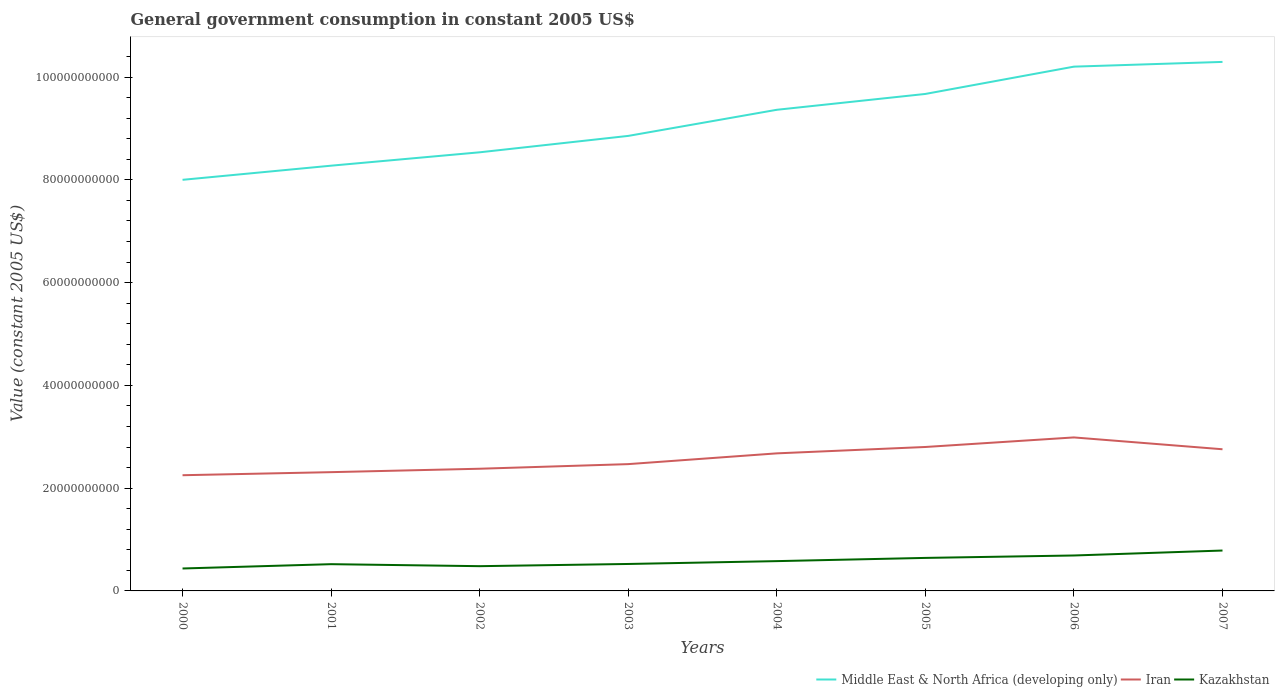Does the line corresponding to Middle East & North Africa (developing only) intersect with the line corresponding to Kazakhstan?
Your response must be concise. No. Across all years, what is the maximum government conusmption in Kazakhstan?
Offer a very short reply. 4.37e+09. What is the total government conusmption in Middle East & North Africa (developing only) in the graph?
Offer a terse response. -2.75e+09. What is the difference between the highest and the second highest government conusmption in Kazakhstan?
Provide a short and direct response. 3.49e+09. Is the government conusmption in Kazakhstan strictly greater than the government conusmption in Iran over the years?
Provide a succinct answer. Yes. How many lines are there?
Your response must be concise. 3. Are the values on the major ticks of Y-axis written in scientific E-notation?
Your answer should be very brief. No. How are the legend labels stacked?
Offer a terse response. Horizontal. What is the title of the graph?
Keep it short and to the point. General government consumption in constant 2005 US$. What is the label or title of the X-axis?
Offer a very short reply. Years. What is the label or title of the Y-axis?
Make the answer very short. Value (constant 2005 US$). What is the Value (constant 2005 US$) of Middle East & North Africa (developing only) in 2000?
Offer a very short reply. 8.00e+1. What is the Value (constant 2005 US$) of Iran in 2000?
Make the answer very short. 2.25e+1. What is the Value (constant 2005 US$) of Kazakhstan in 2000?
Keep it short and to the point. 4.37e+09. What is the Value (constant 2005 US$) in Middle East & North Africa (developing only) in 2001?
Your response must be concise. 8.28e+1. What is the Value (constant 2005 US$) in Iran in 2001?
Your answer should be compact. 2.31e+1. What is the Value (constant 2005 US$) in Kazakhstan in 2001?
Keep it short and to the point. 5.21e+09. What is the Value (constant 2005 US$) in Middle East & North Africa (developing only) in 2002?
Offer a very short reply. 8.54e+1. What is the Value (constant 2005 US$) in Iran in 2002?
Your answer should be compact. 2.38e+1. What is the Value (constant 2005 US$) of Kazakhstan in 2002?
Ensure brevity in your answer.  4.81e+09. What is the Value (constant 2005 US$) of Middle East & North Africa (developing only) in 2003?
Provide a short and direct response. 8.85e+1. What is the Value (constant 2005 US$) of Iran in 2003?
Provide a succinct answer. 2.47e+1. What is the Value (constant 2005 US$) in Kazakhstan in 2003?
Offer a terse response. 5.24e+09. What is the Value (constant 2005 US$) in Middle East & North Africa (developing only) in 2004?
Offer a very short reply. 9.36e+1. What is the Value (constant 2005 US$) in Iran in 2004?
Offer a very short reply. 2.68e+1. What is the Value (constant 2005 US$) of Kazakhstan in 2004?
Provide a short and direct response. 5.80e+09. What is the Value (constant 2005 US$) in Middle East & North Africa (developing only) in 2005?
Provide a succinct answer. 9.67e+1. What is the Value (constant 2005 US$) of Iran in 2005?
Keep it short and to the point. 2.80e+1. What is the Value (constant 2005 US$) of Kazakhstan in 2005?
Provide a succinct answer. 6.43e+09. What is the Value (constant 2005 US$) in Middle East & North Africa (developing only) in 2006?
Keep it short and to the point. 1.02e+11. What is the Value (constant 2005 US$) of Iran in 2006?
Your answer should be very brief. 2.99e+1. What is the Value (constant 2005 US$) of Kazakhstan in 2006?
Your answer should be very brief. 6.89e+09. What is the Value (constant 2005 US$) of Middle East & North Africa (developing only) in 2007?
Your response must be concise. 1.03e+11. What is the Value (constant 2005 US$) in Iran in 2007?
Provide a succinct answer. 2.76e+1. What is the Value (constant 2005 US$) in Kazakhstan in 2007?
Your answer should be compact. 7.86e+09. Across all years, what is the maximum Value (constant 2005 US$) in Middle East & North Africa (developing only)?
Give a very brief answer. 1.03e+11. Across all years, what is the maximum Value (constant 2005 US$) in Iran?
Your response must be concise. 2.99e+1. Across all years, what is the maximum Value (constant 2005 US$) in Kazakhstan?
Offer a very short reply. 7.86e+09. Across all years, what is the minimum Value (constant 2005 US$) in Middle East & North Africa (developing only)?
Make the answer very short. 8.00e+1. Across all years, what is the minimum Value (constant 2005 US$) in Iran?
Offer a terse response. 2.25e+1. Across all years, what is the minimum Value (constant 2005 US$) of Kazakhstan?
Offer a terse response. 4.37e+09. What is the total Value (constant 2005 US$) in Middle East & North Africa (developing only) in the graph?
Provide a short and direct response. 7.32e+11. What is the total Value (constant 2005 US$) in Iran in the graph?
Your answer should be very brief. 2.06e+11. What is the total Value (constant 2005 US$) of Kazakhstan in the graph?
Keep it short and to the point. 4.66e+1. What is the difference between the Value (constant 2005 US$) of Middle East & North Africa (developing only) in 2000 and that in 2001?
Offer a very short reply. -2.75e+09. What is the difference between the Value (constant 2005 US$) of Iran in 2000 and that in 2001?
Your answer should be very brief. -5.96e+08. What is the difference between the Value (constant 2005 US$) of Kazakhstan in 2000 and that in 2001?
Make the answer very short. -8.38e+08. What is the difference between the Value (constant 2005 US$) in Middle East & North Africa (developing only) in 2000 and that in 2002?
Provide a short and direct response. -5.36e+09. What is the difference between the Value (constant 2005 US$) of Iran in 2000 and that in 2002?
Keep it short and to the point. -1.26e+09. What is the difference between the Value (constant 2005 US$) in Kazakhstan in 2000 and that in 2002?
Provide a succinct answer. -4.48e+08. What is the difference between the Value (constant 2005 US$) in Middle East & North Africa (developing only) in 2000 and that in 2003?
Ensure brevity in your answer.  -8.55e+09. What is the difference between the Value (constant 2005 US$) in Iran in 2000 and that in 2003?
Provide a short and direct response. -2.16e+09. What is the difference between the Value (constant 2005 US$) in Kazakhstan in 2000 and that in 2003?
Your answer should be compact. -8.77e+08. What is the difference between the Value (constant 2005 US$) in Middle East & North Africa (developing only) in 2000 and that in 2004?
Give a very brief answer. -1.36e+1. What is the difference between the Value (constant 2005 US$) of Iran in 2000 and that in 2004?
Your answer should be very brief. -4.26e+09. What is the difference between the Value (constant 2005 US$) in Kazakhstan in 2000 and that in 2004?
Keep it short and to the point. -1.43e+09. What is the difference between the Value (constant 2005 US$) in Middle East & North Africa (developing only) in 2000 and that in 2005?
Your answer should be compact. -1.67e+1. What is the difference between the Value (constant 2005 US$) in Iran in 2000 and that in 2005?
Your response must be concise. -5.49e+09. What is the difference between the Value (constant 2005 US$) in Kazakhstan in 2000 and that in 2005?
Keep it short and to the point. -2.06e+09. What is the difference between the Value (constant 2005 US$) of Middle East & North Africa (developing only) in 2000 and that in 2006?
Provide a short and direct response. -2.20e+1. What is the difference between the Value (constant 2005 US$) of Iran in 2000 and that in 2006?
Make the answer very short. -7.36e+09. What is the difference between the Value (constant 2005 US$) in Kazakhstan in 2000 and that in 2006?
Offer a terse response. -2.53e+09. What is the difference between the Value (constant 2005 US$) in Middle East & North Africa (developing only) in 2000 and that in 2007?
Your answer should be very brief. -2.29e+1. What is the difference between the Value (constant 2005 US$) in Iran in 2000 and that in 2007?
Provide a short and direct response. -5.05e+09. What is the difference between the Value (constant 2005 US$) in Kazakhstan in 2000 and that in 2007?
Your answer should be compact. -3.49e+09. What is the difference between the Value (constant 2005 US$) in Middle East & North Africa (developing only) in 2001 and that in 2002?
Your response must be concise. -2.60e+09. What is the difference between the Value (constant 2005 US$) in Iran in 2001 and that in 2002?
Your response must be concise. -6.67e+08. What is the difference between the Value (constant 2005 US$) in Kazakhstan in 2001 and that in 2002?
Your answer should be compact. 3.90e+08. What is the difference between the Value (constant 2005 US$) in Middle East & North Africa (developing only) in 2001 and that in 2003?
Your answer should be compact. -5.79e+09. What is the difference between the Value (constant 2005 US$) of Iran in 2001 and that in 2003?
Your response must be concise. -1.56e+09. What is the difference between the Value (constant 2005 US$) in Kazakhstan in 2001 and that in 2003?
Provide a short and direct response. -3.81e+07. What is the difference between the Value (constant 2005 US$) in Middle East & North Africa (developing only) in 2001 and that in 2004?
Ensure brevity in your answer.  -1.09e+1. What is the difference between the Value (constant 2005 US$) of Iran in 2001 and that in 2004?
Make the answer very short. -3.66e+09. What is the difference between the Value (constant 2005 US$) of Kazakhstan in 2001 and that in 2004?
Your response must be concise. -5.94e+08. What is the difference between the Value (constant 2005 US$) in Middle East & North Africa (developing only) in 2001 and that in 2005?
Provide a short and direct response. -1.40e+1. What is the difference between the Value (constant 2005 US$) in Iran in 2001 and that in 2005?
Provide a succinct answer. -4.90e+09. What is the difference between the Value (constant 2005 US$) in Kazakhstan in 2001 and that in 2005?
Give a very brief answer. -1.22e+09. What is the difference between the Value (constant 2005 US$) in Middle East & North Africa (developing only) in 2001 and that in 2006?
Give a very brief answer. -1.93e+1. What is the difference between the Value (constant 2005 US$) of Iran in 2001 and that in 2006?
Ensure brevity in your answer.  -6.76e+09. What is the difference between the Value (constant 2005 US$) in Kazakhstan in 2001 and that in 2006?
Ensure brevity in your answer.  -1.69e+09. What is the difference between the Value (constant 2005 US$) in Middle East & North Africa (developing only) in 2001 and that in 2007?
Ensure brevity in your answer.  -2.02e+1. What is the difference between the Value (constant 2005 US$) of Iran in 2001 and that in 2007?
Make the answer very short. -4.46e+09. What is the difference between the Value (constant 2005 US$) of Kazakhstan in 2001 and that in 2007?
Your response must be concise. -2.65e+09. What is the difference between the Value (constant 2005 US$) of Middle East & North Africa (developing only) in 2002 and that in 2003?
Give a very brief answer. -3.19e+09. What is the difference between the Value (constant 2005 US$) in Iran in 2002 and that in 2003?
Your answer should be compact. -8.97e+08. What is the difference between the Value (constant 2005 US$) of Kazakhstan in 2002 and that in 2003?
Offer a terse response. -4.29e+08. What is the difference between the Value (constant 2005 US$) of Middle East & North Africa (developing only) in 2002 and that in 2004?
Make the answer very short. -8.27e+09. What is the difference between the Value (constant 2005 US$) in Iran in 2002 and that in 2004?
Give a very brief answer. -2.99e+09. What is the difference between the Value (constant 2005 US$) in Kazakhstan in 2002 and that in 2004?
Your answer should be very brief. -9.84e+08. What is the difference between the Value (constant 2005 US$) in Middle East & North Africa (developing only) in 2002 and that in 2005?
Make the answer very short. -1.14e+1. What is the difference between the Value (constant 2005 US$) of Iran in 2002 and that in 2005?
Your response must be concise. -4.23e+09. What is the difference between the Value (constant 2005 US$) in Kazakhstan in 2002 and that in 2005?
Offer a terse response. -1.61e+09. What is the difference between the Value (constant 2005 US$) of Middle East & North Africa (developing only) in 2002 and that in 2006?
Offer a terse response. -1.67e+1. What is the difference between the Value (constant 2005 US$) in Iran in 2002 and that in 2006?
Provide a short and direct response. -6.09e+09. What is the difference between the Value (constant 2005 US$) of Kazakhstan in 2002 and that in 2006?
Make the answer very short. -2.08e+09. What is the difference between the Value (constant 2005 US$) of Middle East & North Africa (developing only) in 2002 and that in 2007?
Keep it short and to the point. -1.76e+1. What is the difference between the Value (constant 2005 US$) in Iran in 2002 and that in 2007?
Make the answer very short. -3.79e+09. What is the difference between the Value (constant 2005 US$) of Kazakhstan in 2002 and that in 2007?
Make the answer very short. -3.04e+09. What is the difference between the Value (constant 2005 US$) in Middle East & North Africa (developing only) in 2003 and that in 2004?
Your answer should be very brief. -5.08e+09. What is the difference between the Value (constant 2005 US$) in Iran in 2003 and that in 2004?
Ensure brevity in your answer.  -2.09e+09. What is the difference between the Value (constant 2005 US$) of Kazakhstan in 2003 and that in 2004?
Make the answer very short. -5.56e+08. What is the difference between the Value (constant 2005 US$) in Middle East & North Africa (developing only) in 2003 and that in 2005?
Keep it short and to the point. -8.17e+09. What is the difference between the Value (constant 2005 US$) of Iran in 2003 and that in 2005?
Keep it short and to the point. -3.33e+09. What is the difference between the Value (constant 2005 US$) of Kazakhstan in 2003 and that in 2005?
Your answer should be compact. -1.18e+09. What is the difference between the Value (constant 2005 US$) of Middle East & North Africa (developing only) in 2003 and that in 2006?
Offer a terse response. -1.35e+1. What is the difference between the Value (constant 2005 US$) of Iran in 2003 and that in 2006?
Ensure brevity in your answer.  -5.19e+09. What is the difference between the Value (constant 2005 US$) in Kazakhstan in 2003 and that in 2006?
Ensure brevity in your answer.  -1.65e+09. What is the difference between the Value (constant 2005 US$) of Middle East & North Africa (developing only) in 2003 and that in 2007?
Give a very brief answer. -1.44e+1. What is the difference between the Value (constant 2005 US$) in Iran in 2003 and that in 2007?
Your response must be concise. -2.89e+09. What is the difference between the Value (constant 2005 US$) in Kazakhstan in 2003 and that in 2007?
Give a very brief answer. -2.62e+09. What is the difference between the Value (constant 2005 US$) of Middle East & North Africa (developing only) in 2004 and that in 2005?
Your answer should be compact. -3.08e+09. What is the difference between the Value (constant 2005 US$) in Iran in 2004 and that in 2005?
Your answer should be compact. -1.24e+09. What is the difference between the Value (constant 2005 US$) in Kazakhstan in 2004 and that in 2005?
Your response must be concise. -6.26e+08. What is the difference between the Value (constant 2005 US$) of Middle East & North Africa (developing only) in 2004 and that in 2006?
Your answer should be very brief. -8.40e+09. What is the difference between the Value (constant 2005 US$) of Iran in 2004 and that in 2006?
Your answer should be compact. -3.10e+09. What is the difference between the Value (constant 2005 US$) of Kazakhstan in 2004 and that in 2006?
Offer a very short reply. -1.10e+09. What is the difference between the Value (constant 2005 US$) in Middle East & North Africa (developing only) in 2004 and that in 2007?
Provide a succinct answer. -9.32e+09. What is the difference between the Value (constant 2005 US$) of Iran in 2004 and that in 2007?
Offer a terse response. -7.97e+08. What is the difference between the Value (constant 2005 US$) in Kazakhstan in 2004 and that in 2007?
Offer a terse response. -2.06e+09. What is the difference between the Value (constant 2005 US$) in Middle East & North Africa (developing only) in 2005 and that in 2006?
Keep it short and to the point. -5.31e+09. What is the difference between the Value (constant 2005 US$) in Iran in 2005 and that in 2006?
Give a very brief answer. -1.86e+09. What is the difference between the Value (constant 2005 US$) in Kazakhstan in 2005 and that in 2006?
Ensure brevity in your answer.  -4.69e+08. What is the difference between the Value (constant 2005 US$) in Middle East & North Africa (developing only) in 2005 and that in 2007?
Your answer should be very brief. -6.23e+09. What is the difference between the Value (constant 2005 US$) in Iran in 2005 and that in 2007?
Keep it short and to the point. 4.43e+08. What is the difference between the Value (constant 2005 US$) in Kazakhstan in 2005 and that in 2007?
Give a very brief answer. -1.43e+09. What is the difference between the Value (constant 2005 US$) in Middle East & North Africa (developing only) in 2006 and that in 2007?
Keep it short and to the point. -9.21e+08. What is the difference between the Value (constant 2005 US$) of Iran in 2006 and that in 2007?
Provide a short and direct response. 2.30e+09. What is the difference between the Value (constant 2005 US$) of Kazakhstan in 2006 and that in 2007?
Give a very brief answer. -9.65e+08. What is the difference between the Value (constant 2005 US$) of Middle East & North Africa (developing only) in 2000 and the Value (constant 2005 US$) of Iran in 2001?
Ensure brevity in your answer.  5.69e+1. What is the difference between the Value (constant 2005 US$) of Middle East & North Africa (developing only) in 2000 and the Value (constant 2005 US$) of Kazakhstan in 2001?
Your answer should be very brief. 7.48e+1. What is the difference between the Value (constant 2005 US$) in Iran in 2000 and the Value (constant 2005 US$) in Kazakhstan in 2001?
Your answer should be very brief. 1.73e+1. What is the difference between the Value (constant 2005 US$) in Middle East & North Africa (developing only) in 2000 and the Value (constant 2005 US$) in Iran in 2002?
Provide a succinct answer. 5.62e+1. What is the difference between the Value (constant 2005 US$) of Middle East & North Africa (developing only) in 2000 and the Value (constant 2005 US$) of Kazakhstan in 2002?
Your response must be concise. 7.52e+1. What is the difference between the Value (constant 2005 US$) in Iran in 2000 and the Value (constant 2005 US$) in Kazakhstan in 2002?
Ensure brevity in your answer.  1.77e+1. What is the difference between the Value (constant 2005 US$) of Middle East & North Africa (developing only) in 2000 and the Value (constant 2005 US$) of Iran in 2003?
Offer a terse response. 5.53e+1. What is the difference between the Value (constant 2005 US$) of Middle East & North Africa (developing only) in 2000 and the Value (constant 2005 US$) of Kazakhstan in 2003?
Offer a very short reply. 7.48e+1. What is the difference between the Value (constant 2005 US$) in Iran in 2000 and the Value (constant 2005 US$) in Kazakhstan in 2003?
Provide a short and direct response. 1.73e+1. What is the difference between the Value (constant 2005 US$) in Middle East & North Africa (developing only) in 2000 and the Value (constant 2005 US$) in Iran in 2004?
Keep it short and to the point. 5.32e+1. What is the difference between the Value (constant 2005 US$) of Middle East & North Africa (developing only) in 2000 and the Value (constant 2005 US$) of Kazakhstan in 2004?
Your answer should be very brief. 7.42e+1. What is the difference between the Value (constant 2005 US$) of Iran in 2000 and the Value (constant 2005 US$) of Kazakhstan in 2004?
Ensure brevity in your answer.  1.67e+1. What is the difference between the Value (constant 2005 US$) of Middle East & North Africa (developing only) in 2000 and the Value (constant 2005 US$) of Iran in 2005?
Your response must be concise. 5.20e+1. What is the difference between the Value (constant 2005 US$) in Middle East & North Africa (developing only) in 2000 and the Value (constant 2005 US$) in Kazakhstan in 2005?
Your response must be concise. 7.36e+1. What is the difference between the Value (constant 2005 US$) of Iran in 2000 and the Value (constant 2005 US$) of Kazakhstan in 2005?
Offer a very short reply. 1.61e+1. What is the difference between the Value (constant 2005 US$) of Middle East & North Africa (developing only) in 2000 and the Value (constant 2005 US$) of Iran in 2006?
Your answer should be compact. 5.01e+1. What is the difference between the Value (constant 2005 US$) of Middle East & North Africa (developing only) in 2000 and the Value (constant 2005 US$) of Kazakhstan in 2006?
Keep it short and to the point. 7.31e+1. What is the difference between the Value (constant 2005 US$) in Iran in 2000 and the Value (constant 2005 US$) in Kazakhstan in 2006?
Offer a terse response. 1.56e+1. What is the difference between the Value (constant 2005 US$) in Middle East & North Africa (developing only) in 2000 and the Value (constant 2005 US$) in Iran in 2007?
Your answer should be very brief. 5.24e+1. What is the difference between the Value (constant 2005 US$) in Middle East & North Africa (developing only) in 2000 and the Value (constant 2005 US$) in Kazakhstan in 2007?
Your answer should be very brief. 7.21e+1. What is the difference between the Value (constant 2005 US$) of Iran in 2000 and the Value (constant 2005 US$) of Kazakhstan in 2007?
Offer a very short reply. 1.47e+1. What is the difference between the Value (constant 2005 US$) of Middle East & North Africa (developing only) in 2001 and the Value (constant 2005 US$) of Iran in 2002?
Ensure brevity in your answer.  5.90e+1. What is the difference between the Value (constant 2005 US$) of Middle East & North Africa (developing only) in 2001 and the Value (constant 2005 US$) of Kazakhstan in 2002?
Your response must be concise. 7.79e+1. What is the difference between the Value (constant 2005 US$) in Iran in 2001 and the Value (constant 2005 US$) in Kazakhstan in 2002?
Offer a terse response. 1.83e+1. What is the difference between the Value (constant 2005 US$) in Middle East & North Africa (developing only) in 2001 and the Value (constant 2005 US$) in Iran in 2003?
Provide a short and direct response. 5.81e+1. What is the difference between the Value (constant 2005 US$) in Middle East & North Africa (developing only) in 2001 and the Value (constant 2005 US$) in Kazakhstan in 2003?
Provide a succinct answer. 7.75e+1. What is the difference between the Value (constant 2005 US$) in Iran in 2001 and the Value (constant 2005 US$) in Kazakhstan in 2003?
Offer a terse response. 1.79e+1. What is the difference between the Value (constant 2005 US$) in Middle East & North Africa (developing only) in 2001 and the Value (constant 2005 US$) in Iran in 2004?
Give a very brief answer. 5.60e+1. What is the difference between the Value (constant 2005 US$) in Middle East & North Africa (developing only) in 2001 and the Value (constant 2005 US$) in Kazakhstan in 2004?
Your answer should be very brief. 7.70e+1. What is the difference between the Value (constant 2005 US$) in Iran in 2001 and the Value (constant 2005 US$) in Kazakhstan in 2004?
Provide a short and direct response. 1.73e+1. What is the difference between the Value (constant 2005 US$) in Middle East & North Africa (developing only) in 2001 and the Value (constant 2005 US$) in Iran in 2005?
Provide a short and direct response. 5.47e+1. What is the difference between the Value (constant 2005 US$) in Middle East & North Africa (developing only) in 2001 and the Value (constant 2005 US$) in Kazakhstan in 2005?
Your answer should be very brief. 7.63e+1. What is the difference between the Value (constant 2005 US$) in Iran in 2001 and the Value (constant 2005 US$) in Kazakhstan in 2005?
Make the answer very short. 1.67e+1. What is the difference between the Value (constant 2005 US$) in Middle East & North Africa (developing only) in 2001 and the Value (constant 2005 US$) in Iran in 2006?
Your response must be concise. 5.29e+1. What is the difference between the Value (constant 2005 US$) of Middle East & North Africa (developing only) in 2001 and the Value (constant 2005 US$) of Kazakhstan in 2006?
Offer a very short reply. 7.59e+1. What is the difference between the Value (constant 2005 US$) in Iran in 2001 and the Value (constant 2005 US$) in Kazakhstan in 2006?
Provide a succinct answer. 1.62e+1. What is the difference between the Value (constant 2005 US$) in Middle East & North Africa (developing only) in 2001 and the Value (constant 2005 US$) in Iran in 2007?
Offer a terse response. 5.52e+1. What is the difference between the Value (constant 2005 US$) of Middle East & North Africa (developing only) in 2001 and the Value (constant 2005 US$) of Kazakhstan in 2007?
Keep it short and to the point. 7.49e+1. What is the difference between the Value (constant 2005 US$) of Iran in 2001 and the Value (constant 2005 US$) of Kazakhstan in 2007?
Offer a very short reply. 1.53e+1. What is the difference between the Value (constant 2005 US$) in Middle East & North Africa (developing only) in 2002 and the Value (constant 2005 US$) in Iran in 2003?
Your response must be concise. 6.07e+1. What is the difference between the Value (constant 2005 US$) in Middle East & North Africa (developing only) in 2002 and the Value (constant 2005 US$) in Kazakhstan in 2003?
Make the answer very short. 8.01e+1. What is the difference between the Value (constant 2005 US$) in Iran in 2002 and the Value (constant 2005 US$) in Kazakhstan in 2003?
Offer a terse response. 1.85e+1. What is the difference between the Value (constant 2005 US$) of Middle East & North Africa (developing only) in 2002 and the Value (constant 2005 US$) of Iran in 2004?
Offer a very short reply. 5.86e+1. What is the difference between the Value (constant 2005 US$) of Middle East & North Africa (developing only) in 2002 and the Value (constant 2005 US$) of Kazakhstan in 2004?
Make the answer very short. 7.96e+1. What is the difference between the Value (constant 2005 US$) in Iran in 2002 and the Value (constant 2005 US$) in Kazakhstan in 2004?
Make the answer very short. 1.80e+1. What is the difference between the Value (constant 2005 US$) of Middle East & North Africa (developing only) in 2002 and the Value (constant 2005 US$) of Iran in 2005?
Provide a short and direct response. 5.73e+1. What is the difference between the Value (constant 2005 US$) of Middle East & North Africa (developing only) in 2002 and the Value (constant 2005 US$) of Kazakhstan in 2005?
Your response must be concise. 7.89e+1. What is the difference between the Value (constant 2005 US$) of Iran in 2002 and the Value (constant 2005 US$) of Kazakhstan in 2005?
Offer a very short reply. 1.74e+1. What is the difference between the Value (constant 2005 US$) of Middle East & North Africa (developing only) in 2002 and the Value (constant 2005 US$) of Iran in 2006?
Offer a terse response. 5.55e+1. What is the difference between the Value (constant 2005 US$) of Middle East & North Africa (developing only) in 2002 and the Value (constant 2005 US$) of Kazakhstan in 2006?
Give a very brief answer. 7.85e+1. What is the difference between the Value (constant 2005 US$) in Iran in 2002 and the Value (constant 2005 US$) in Kazakhstan in 2006?
Offer a terse response. 1.69e+1. What is the difference between the Value (constant 2005 US$) of Middle East & North Africa (developing only) in 2002 and the Value (constant 2005 US$) of Iran in 2007?
Offer a terse response. 5.78e+1. What is the difference between the Value (constant 2005 US$) of Middle East & North Africa (developing only) in 2002 and the Value (constant 2005 US$) of Kazakhstan in 2007?
Your response must be concise. 7.75e+1. What is the difference between the Value (constant 2005 US$) in Iran in 2002 and the Value (constant 2005 US$) in Kazakhstan in 2007?
Offer a very short reply. 1.59e+1. What is the difference between the Value (constant 2005 US$) of Middle East & North Africa (developing only) in 2003 and the Value (constant 2005 US$) of Iran in 2004?
Your response must be concise. 6.18e+1. What is the difference between the Value (constant 2005 US$) in Middle East & North Africa (developing only) in 2003 and the Value (constant 2005 US$) in Kazakhstan in 2004?
Offer a terse response. 8.27e+1. What is the difference between the Value (constant 2005 US$) of Iran in 2003 and the Value (constant 2005 US$) of Kazakhstan in 2004?
Give a very brief answer. 1.89e+1. What is the difference between the Value (constant 2005 US$) of Middle East & North Africa (developing only) in 2003 and the Value (constant 2005 US$) of Iran in 2005?
Your answer should be compact. 6.05e+1. What is the difference between the Value (constant 2005 US$) of Middle East & North Africa (developing only) in 2003 and the Value (constant 2005 US$) of Kazakhstan in 2005?
Keep it short and to the point. 8.21e+1. What is the difference between the Value (constant 2005 US$) of Iran in 2003 and the Value (constant 2005 US$) of Kazakhstan in 2005?
Offer a terse response. 1.82e+1. What is the difference between the Value (constant 2005 US$) of Middle East & North Africa (developing only) in 2003 and the Value (constant 2005 US$) of Iran in 2006?
Keep it short and to the point. 5.87e+1. What is the difference between the Value (constant 2005 US$) in Middle East & North Africa (developing only) in 2003 and the Value (constant 2005 US$) in Kazakhstan in 2006?
Offer a very short reply. 8.17e+1. What is the difference between the Value (constant 2005 US$) in Iran in 2003 and the Value (constant 2005 US$) in Kazakhstan in 2006?
Ensure brevity in your answer.  1.78e+1. What is the difference between the Value (constant 2005 US$) in Middle East & North Africa (developing only) in 2003 and the Value (constant 2005 US$) in Iran in 2007?
Your answer should be compact. 6.10e+1. What is the difference between the Value (constant 2005 US$) of Middle East & North Africa (developing only) in 2003 and the Value (constant 2005 US$) of Kazakhstan in 2007?
Keep it short and to the point. 8.07e+1. What is the difference between the Value (constant 2005 US$) in Iran in 2003 and the Value (constant 2005 US$) in Kazakhstan in 2007?
Offer a very short reply. 1.68e+1. What is the difference between the Value (constant 2005 US$) in Middle East & North Africa (developing only) in 2004 and the Value (constant 2005 US$) in Iran in 2005?
Offer a very short reply. 6.56e+1. What is the difference between the Value (constant 2005 US$) in Middle East & North Africa (developing only) in 2004 and the Value (constant 2005 US$) in Kazakhstan in 2005?
Your response must be concise. 8.72e+1. What is the difference between the Value (constant 2005 US$) in Iran in 2004 and the Value (constant 2005 US$) in Kazakhstan in 2005?
Your answer should be very brief. 2.03e+1. What is the difference between the Value (constant 2005 US$) in Middle East & North Africa (developing only) in 2004 and the Value (constant 2005 US$) in Iran in 2006?
Offer a terse response. 6.38e+1. What is the difference between the Value (constant 2005 US$) in Middle East & North Africa (developing only) in 2004 and the Value (constant 2005 US$) in Kazakhstan in 2006?
Keep it short and to the point. 8.67e+1. What is the difference between the Value (constant 2005 US$) of Iran in 2004 and the Value (constant 2005 US$) of Kazakhstan in 2006?
Keep it short and to the point. 1.99e+1. What is the difference between the Value (constant 2005 US$) of Middle East & North Africa (developing only) in 2004 and the Value (constant 2005 US$) of Iran in 2007?
Keep it short and to the point. 6.61e+1. What is the difference between the Value (constant 2005 US$) of Middle East & North Africa (developing only) in 2004 and the Value (constant 2005 US$) of Kazakhstan in 2007?
Keep it short and to the point. 8.58e+1. What is the difference between the Value (constant 2005 US$) in Iran in 2004 and the Value (constant 2005 US$) in Kazakhstan in 2007?
Offer a terse response. 1.89e+1. What is the difference between the Value (constant 2005 US$) of Middle East & North Africa (developing only) in 2005 and the Value (constant 2005 US$) of Iran in 2006?
Offer a terse response. 6.68e+1. What is the difference between the Value (constant 2005 US$) in Middle East & North Africa (developing only) in 2005 and the Value (constant 2005 US$) in Kazakhstan in 2006?
Offer a very short reply. 8.98e+1. What is the difference between the Value (constant 2005 US$) of Iran in 2005 and the Value (constant 2005 US$) of Kazakhstan in 2006?
Make the answer very short. 2.11e+1. What is the difference between the Value (constant 2005 US$) in Middle East & North Africa (developing only) in 2005 and the Value (constant 2005 US$) in Iran in 2007?
Offer a terse response. 6.91e+1. What is the difference between the Value (constant 2005 US$) in Middle East & North Africa (developing only) in 2005 and the Value (constant 2005 US$) in Kazakhstan in 2007?
Your answer should be compact. 8.89e+1. What is the difference between the Value (constant 2005 US$) in Iran in 2005 and the Value (constant 2005 US$) in Kazakhstan in 2007?
Provide a short and direct response. 2.01e+1. What is the difference between the Value (constant 2005 US$) of Middle East & North Africa (developing only) in 2006 and the Value (constant 2005 US$) of Iran in 2007?
Give a very brief answer. 7.45e+1. What is the difference between the Value (constant 2005 US$) in Middle East & North Africa (developing only) in 2006 and the Value (constant 2005 US$) in Kazakhstan in 2007?
Provide a short and direct response. 9.42e+1. What is the difference between the Value (constant 2005 US$) of Iran in 2006 and the Value (constant 2005 US$) of Kazakhstan in 2007?
Your answer should be very brief. 2.20e+1. What is the average Value (constant 2005 US$) in Middle East & North Africa (developing only) per year?
Provide a short and direct response. 9.15e+1. What is the average Value (constant 2005 US$) in Iran per year?
Offer a very short reply. 2.58e+1. What is the average Value (constant 2005 US$) in Kazakhstan per year?
Your answer should be compact. 5.83e+09. In the year 2000, what is the difference between the Value (constant 2005 US$) of Middle East & North Africa (developing only) and Value (constant 2005 US$) of Iran?
Provide a short and direct response. 5.75e+1. In the year 2000, what is the difference between the Value (constant 2005 US$) of Middle East & North Africa (developing only) and Value (constant 2005 US$) of Kazakhstan?
Offer a terse response. 7.56e+1. In the year 2000, what is the difference between the Value (constant 2005 US$) of Iran and Value (constant 2005 US$) of Kazakhstan?
Offer a very short reply. 1.81e+1. In the year 2001, what is the difference between the Value (constant 2005 US$) in Middle East & North Africa (developing only) and Value (constant 2005 US$) in Iran?
Your response must be concise. 5.96e+1. In the year 2001, what is the difference between the Value (constant 2005 US$) in Middle East & North Africa (developing only) and Value (constant 2005 US$) in Kazakhstan?
Keep it short and to the point. 7.75e+1. In the year 2001, what is the difference between the Value (constant 2005 US$) in Iran and Value (constant 2005 US$) in Kazakhstan?
Offer a very short reply. 1.79e+1. In the year 2002, what is the difference between the Value (constant 2005 US$) of Middle East & North Africa (developing only) and Value (constant 2005 US$) of Iran?
Your answer should be compact. 6.16e+1. In the year 2002, what is the difference between the Value (constant 2005 US$) of Middle East & North Africa (developing only) and Value (constant 2005 US$) of Kazakhstan?
Offer a very short reply. 8.05e+1. In the year 2002, what is the difference between the Value (constant 2005 US$) in Iran and Value (constant 2005 US$) in Kazakhstan?
Your response must be concise. 1.90e+1. In the year 2003, what is the difference between the Value (constant 2005 US$) in Middle East & North Africa (developing only) and Value (constant 2005 US$) in Iran?
Provide a succinct answer. 6.39e+1. In the year 2003, what is the difference between the Value (constant 2005 US$) of Middle East & North Africa (developing only) and Value (constant 2005 US$) of Kazakhstan?
Your answer should be compact. 8.33e+1. In the year 2003, what is the difference between the Value (constant 2005 US$) in Iran and Value (constant 2005 US$) in Kazakhstan?
Ensure brevity in your answer.  1.94e+1. In the year 2004, what is the difference between the Value (constant 2005 US$) in Middle East & North Africa (developing only) and Value (constant 2005 US$) in Iran?
Your answer should be compact. 6.69e+1. In the year 2004, what is the difference between the Value (constant 2005 US$) in Middle East & North Africa (developing only) and Value (constant 2005 US$) in Kazakhstan?
Your response must be concise. 8.78e+1. In the year 2004, what is the difference between the Value (constant 2005 US$) in Iran and Value (constant 2005 US$) in Kazakhstan?
Your answer should be compact. 2.10e+1. In the year 2005, what is the difference between the Value (constant 2005 US$) in Middle East & North Africa (developing only) and Value (constant 2005 US$) in Iran?
Ensure brevity in your answer.  6.87e+1. In the year 2005, what is the difference between the Value (constant 2005 US$) in Middle East & North Africa (developing only) and Value (constant 2005 US$) in Kazakhstan?
Make the answer very short. 9.03e+1. In the year 2005, what is the difference between the Value (constant 2005 US$) in Iran and Value (constant 2005 US$) in Kazakhstan?
Keep it short and to the point. 2.16e+1. In the year 2006, what is the difference between the Value (constant 2005 US$) of Middle East & North Africa (developing only) and Value (constant 2005 US$) of Iran?
Provide a short and direct response. 7.22e+1. In the year 2006, what is the difference between the Value (constant 2005 US$) of Middle East & North Africa (developing only) and Value (constant 2005 US$) of Kazakhstan?
Your response must be concise. 9.51e+1. In the year 2006, what is the difference between the Value (constant 2005 US$) of Iran and Value (constant 2005 US$) of Kazakhstan?
Your answer should be very brief. 2.30e+1. In the year 2007, what is the difference between the Value (constant 2005 US$) in Middle East & North Africa (developing only) and Value (constant 2005 US$) in Iran?
Provide a succinct answer. 7.54e+1. In the year 2007, what is the difference between the Value (constant 2005 US$) of Middle East & North Africa (developing only) and Value (constant 2005 US$) of Kazakhstan?
Provide a succinct answer. 9.51e+1. In the year 2007, what is the difference between the Value (constant 2005 US$) in Iran and Value (constant 2005 US$) in Kazakhstan?
Your answer should be very brief. 1.97e+1. What is the ratio of the Value (constant 2005 US$) in Middle East & North Africa (developing only) in 2000 to that in 2001?
Your answer should be compact. 0.97. What is the ratio of the Value (constant 2005 US$) of Iran in 2000 to that in 2001?
Offer a very short reply. 0.97. What is the ratio of the Value (constant 2005 US$) of Kazakhstan in 2000 to that in 2001?
Offer a very short reply. 0.84. What is the ratio of the Value (constant 2005 US$) of Middle East & North Africa (developing only) in 2000 to that in 2002?
Make the answer very short. 0.94. What is the ratio of the Value (constant 2005 US$) in Iran in 2000 to that in 2002?
Give a very brief answer. 0.95. What is the ratio of the Value (constant 2005 US$) in Kazakhstan in 2000 to that in 2002?
Your answer should be compact. 0.91. What is the ratio of the Value (constant 2005 US$) of Middle East & North Africa (developing only) in 2000 to that in 2003?
Your answer should be compact. 0.9. What is the ratio of the Value (constant 2005 US$) of Iran in 2000 to that in 2003?
Ensure brevity in your answer.  0.91. What is the ratio of the Value (constant 2005 US$) in Kazakhstan in 2000 to that in 2003?
Your response must be concise. 0.83. What is the ratio of the Value (constant 2005 US$) of Middle East & North Africa (developing only) in 2000 to that in 2004?
Your answer should be very brief. 0.85. What is the ratio of the Value (constant 2005 US$) of Iran in 2000 to that in 2004?
Your answer should be very brief. 0.84. What is the ratio of the Value (constant 2005 US$) in Kazakhstan in 2000 to that in 2004?
Your answer should be compact. 0.75. What is the ratio of the Value (constant 2005 US$) in Middle East & North Africa (developing only) in 2000 to that in 2005?
Make the answer very short. 0.83. What is the ratio of the Value (constant 2005 US$) of Iran in 2000 to that in 2005?
Provide a short and direct response. 0.8. What is the ratio of the Value (constant 2005 US$) of Kazakhstan in 2000 to that in 2005?
Your response must be concise. 0.68. What is the ratio of the Value (constant 2005 US$) in Middle East & North Africa (developing only) in 2000 to that in 2006?
Make the answer very short. 0.78. What is the ratio of the Value (constant 2005 US$) in Iran in 2000 to that in 2006?
Provide a succinct answer. 0.75. What is the ratio of the Value (constant 2005 US$) in Kazakhstan in 2000 to that in 2006?
Make the answer very short. 0.63. What is the ratio of the Value (constant 2005 US$) of Middle East & North Africa (developing only) in 2000 to that in 2007?
Keep it short and to the point. 0.78. What is the ratio of the Value (constant 2005 US$) of Iran in 2000 to that in 2007?
Your response must be concise. 0.82. What is the ratio of the Value (constant 2005 US$) of Kazakhstan in 2000 to that in 2007?
Your answer should be very brief. 0.56. What is the ratio of the Value (constant 2005 US$) in Middle East & North Africa (developing only) in 2001 to that in 2002?
Offer a very short reply. 0.97. What is the ratio of the Value (constant 2005 US$) of Iran in 2001 to that in 2002?
Keep it short and to the point. 0.97. What is the ratio of the Value (constant 2005 US$) of Kazakhstan in 2001 to that in 2002?
Ensure brevity in your answer.  1.08. What is the ratio of the Value (constant 2005 US$) of Middle East & North Africa (developing only) in 2001 to that in 2003?
Your answer should be compact. 0.93. What is the ratio of the Value (constant 2005 US$) in Iran in 2001 to that in 2003?
Your response must be concise. 0.94. What is the ratio of the Value (constant 2005 US$) in Kazakhstan in 2001 to that in 2003?
Keep it short and to the point. 0.99. What is the ratio of the Value (constant 2005 US$) of Middle East & North Africa (developing only) in 2001 to that in 2004?
Your answer should be compact. 0.88. What is the ratio of the Value (constant 2005 US$) of Iran in 2001 to that in 2004?
Give a very brief answer. 0.86. What is the ratio of the Value (constant 2005 US$) of Kazakhstan in 2001 to that in 2004?
Your answer should be very brief. 0.9. What is the ratio of the Value (constant 2005 US$) of Middle East & North Africa (developing only) in 2001 to that in 2005?
Ensure brevity in your answer.  0.86. What is the ratio of the Value (constant 2005 US$) of Iran in 2001 to that in 2005?
Provide a short and direct response. 0.83. What is the ratio of the Value (constant 2005 US$) in Kazakhstan in 2001 to that in 2005?
Offer a terse response. 0.81. What is the ratio of the Value (constant 2005 US$) in Middle East & North Africa (developing only) in 2001 to that in 2006?
Your response must be concise. 0.81. What is the ratio of the Value (constant 2005 US$) of Iran in 2001 to that in 2006?
Keep it short and to the point. 0.77. What is the ratio of the Value (constant 2005 US$) of Kazakhstan in 2001 to that in 2006?
Keep it short and to the point. 0.76. What is the ratio of the Value (constant 2005 US$) in Middle East & North Africa (developing only) in 2001 to that in 2007?
Offer a very short reply. 0.8. What is the ratio of the Value (constant 2005 US$) in Iran in 2001 to that in 2007?
Provide a succinct answer. 0.84. What is the ratio of the Value (constant 2005 US$) in Kazakhstan in 2001 to that in 2007?
Provide a short and direct response. 0.66. What is the ratio of the Value (constant 2005 US$) of Iran in 2002 to that in 2003?
Your response must be concise. 0.96. What is the ratio of the Value (constant 2005 US$) in Kazakhstan in 2002 to that in 2003?
Provide a succinct answer. 0.92. What is the ratio of the Value (constant 2005 US$) of Middle East & North Africa (developing only) in 2002 to that in 2004?
Keep it short and to the point. 0.91. What is the ratio of the Value (constant 2005 US$) of Iran in 2002 to that in 2004?
Make the answer very short. 0.89. What is the ratio of the Value (constant 2005 US$) of Kazakhstan in 2002 to that in 2004?
Your answer should be compact. 0.83. What is the ratio of the Value (constant 2005 US$) of Middle East & North Africa (developing only) in 2002 to that in 2005?
Your response must be concise. 0.88. What is the ratio of the Value (constant 2005 US$) in Iran in 2002 to that in 2005?
Offer a very short reply. 0.85. What is the ratio of the Value (constant 2005 US$) of Kazakhstan in 2002 to that in 2005?
Make the answer very short. 0.75. What is the ratio of the Value (constant 2005 US$) in Middle East & North Africa (developing only) in 2002 to that in 2006?
Your answer should be very brief. 0.84. What is the ratio of the Value (constant 2005 US$) in Iran in 2002 to that in 2006?
Your answer should be compact. 0.8. What is the ratio of the Value (constant 2005 US$) of Kazakhstan in 2002 to that in 2006?
Make the answer very short. 0.7. What is the ratio of the Value (constant 2005 US$) of Middle East & North Africa (developing only) in 2002 to that in 2007?
Your answer should be compact. 0.83. What is the ratio of the Value (constant 2005 US$) in Iran in 2002 to that in 2007?
Your answer should be compact. 0.86. What is the ratio of the Value (constant 2005 US$) in Kazakhstan in 2002 to that in 2007?
Provide a short and direct response. 0.61. What is the ratio of the Value (constant 2005 US$) in Middle East & North Africa (developing only) in 2003 to that in 2004?
Give a very brief answer. 0.95. What is the ratio of the Value (constant 2005 US$) of Iran in 2003 to that in 2004?
Offer a very short reply. 0.92. What is the ratio of the Value (constant 2005 US$) in Kazakhstan in 2003 to that in 2004?
Your answer should be compact. 0.9. What is the ratio of the Value (constant 2005 US$) of Middle East & North Africa (developing only) in 2003 to that in 2005?
Offer a very short reply. 0.92. What is the ratio of the Value (constant 2005 US$) of Iran in 2003 to that in 2005?
Keep it short and to the point. 0.88. What is the ratio of the Value (constant 2005 US$) of Kazakhstan in 2003 to that in 2005?
Make the answer very short. 0.82. What is the ratio of the Value (constant 2005 US$) of Middle East & North Africa (developing only) in 2003 to that in 2006?
Give a very brief answer. 0.87. What is the ratio of the Value (constant 2005 US$) of Iran in 2003 to that in 2006?
Provide a succinct answer. 0.83. What is the ratio of the Value (constant 2005 US$) of Kazakhstan in 2003 to that in 2006?
Provide a short and direct response. 0.76. What is the ratio of the Value (constant 2005 US$) in Middle East & North Africa (developing only) in 2003 to that in 2007?
Ensure brevity in your answer.  0.86. What is the ratio of the Value (constant 2005 US$) in Iran in 2003 to that in 2007?
Provide a succinct answer. 0.9. What is the ratio of the Value (constant 2005 US$) of Kazakhstan in 2003 to that in 2007?
Offer a terse response. 0.67. What is the ratio of the Value (constant 2005 US$) in Middle East & North Africa (developing only) in 2004 to that in 2005?
Your response must be concise. 0.97. What is the ratio of the Value (constant 2005 US$) of Iran in 2004 to that in 2005?
Give a very brief answer. 0.96. What is the ratio of the Value (constant 2005 US$) of Kazakhstan in 2004 to that in 2005?
Give a very brief answer. 0.9. What is the ratio of the Value (constant 2005 US$) of Middle East & North Africa (developing only) in 2004 to that in 2006?
Make the answer very short. 0.92. What is the ratio of the Value (constant 2005 US$) in Iran in 2004 to that in 2006?
Make the answer very short. 0.9. What is the ratio of the Value (constant 2005 US$) in Kazakhstan in 2004 to that in 2006?
Offer a very short reply. 0.84. What is the ratio of the Value (constant 2005 US$) in Middle East & North Africa (developing only) in 2004 to that in 2007?
Ensure brevity in your answer.  0.91. What is the ratio of the Value (constant 2005 US$) in Iran in 2004 to that in 2007?
Your answer should be very brief. 0.97. What is the ratio of the Value (constant 2005 US$) of Kazakhstan in 2004 to that in 2007?
Provide a succinct answer. 0.74. What is the ratio of the Value (constant 2005 US$) of Middle East & North Africa (developing only) in 2005 to that in 2006?
Your response must be concise. 0.95. What is the ratio of the Value (constant 2005 US$) of Iran in 2005 to that in 2006?
Give a very brief answer. 0.94. What is the ratio of the Value (constant 2005 US$) in Kazakhstan in 2005 to that in 2006?
Keep it short and to the point. 0.93. What is the ratio of the Value (constant 2005 US$) in Middle East & North Africa (developing only) in 2005 to that in 2007?
Keep it short and to the point. 0.94. What is the ratio of the Value (constant 2005 US$) in Iran in 2005 to that in 2007?
Offer a terse response. 1.02. What is the ratio of the Value (constant 2005 US$) in Kazakhstan in 2005 to that in 2007?
Give a very brief answer. 0.82. What is the ratio of the Value (constant 2005 US$) of Iran in 2006 to that in 2007?
Your answer should be very brief. 1.08. What is the ratio of the Value (constant 2005 US$) of Kazakhstan in 2006 to that in 2007?
Keep it short and to the point. 0.88. What is the difference between the highest and the second highest Value (constant 2005 US$) of Middle East & North Africa (developing only)?
Make the answer very short. 9.21e+08. What is the difference between the highest and the second highest Value (constant 2005 US$) of Iran?
Provide a succinct answer. 1.86e+09. What is the difference between the highest and the second highest Value (constant 2005 US$) of Kazakhstan?
Keep it short and to the point. 9.65e+08. What is the difference between the highest and the lowest Value (constant 2005 US$) in Middle East & North Africa (developing only)?
Your answer should be very brief. 2.29e+1. What is the difference between the highest and the lowest Value (constant 2005 US$) of Iran?
Offer a terse response. 7.36e+09. What is the difference between the highest and the lowest Value (constant 2005 US$) in Kazakhstan?
Give a very brief answer. 3.49e+09. 